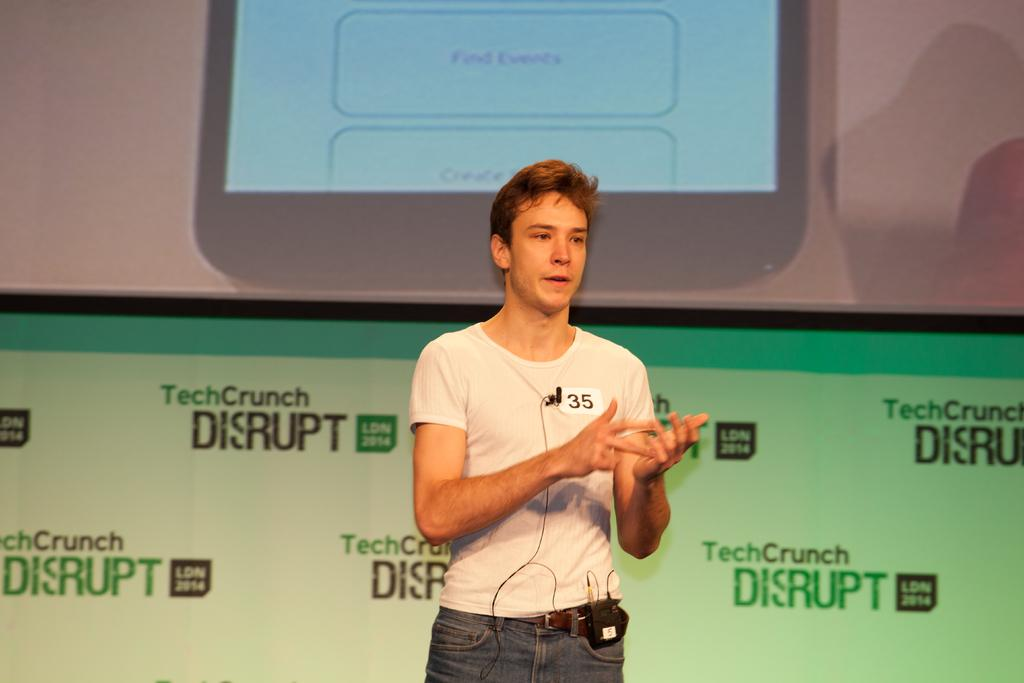What is the main subject of the image? There is a man standing in the center of the image. What can be seen in the background of the image? There is a screen and a board in the background of the image. What type of dress is the man wearing in the image? The man is not wearing a dress in the image; he is wearing regular clothing. What kind of nut can be seen on the board in the image? There is no nut present on the board in the image. 